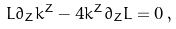<formula> <loc_0><loc_0><loc_500><loc_500>L \partial _ { Z } k ^ { Z } - 4 k ^ { Z } \partial _ { Z } L = 0 \, ,</formula> 